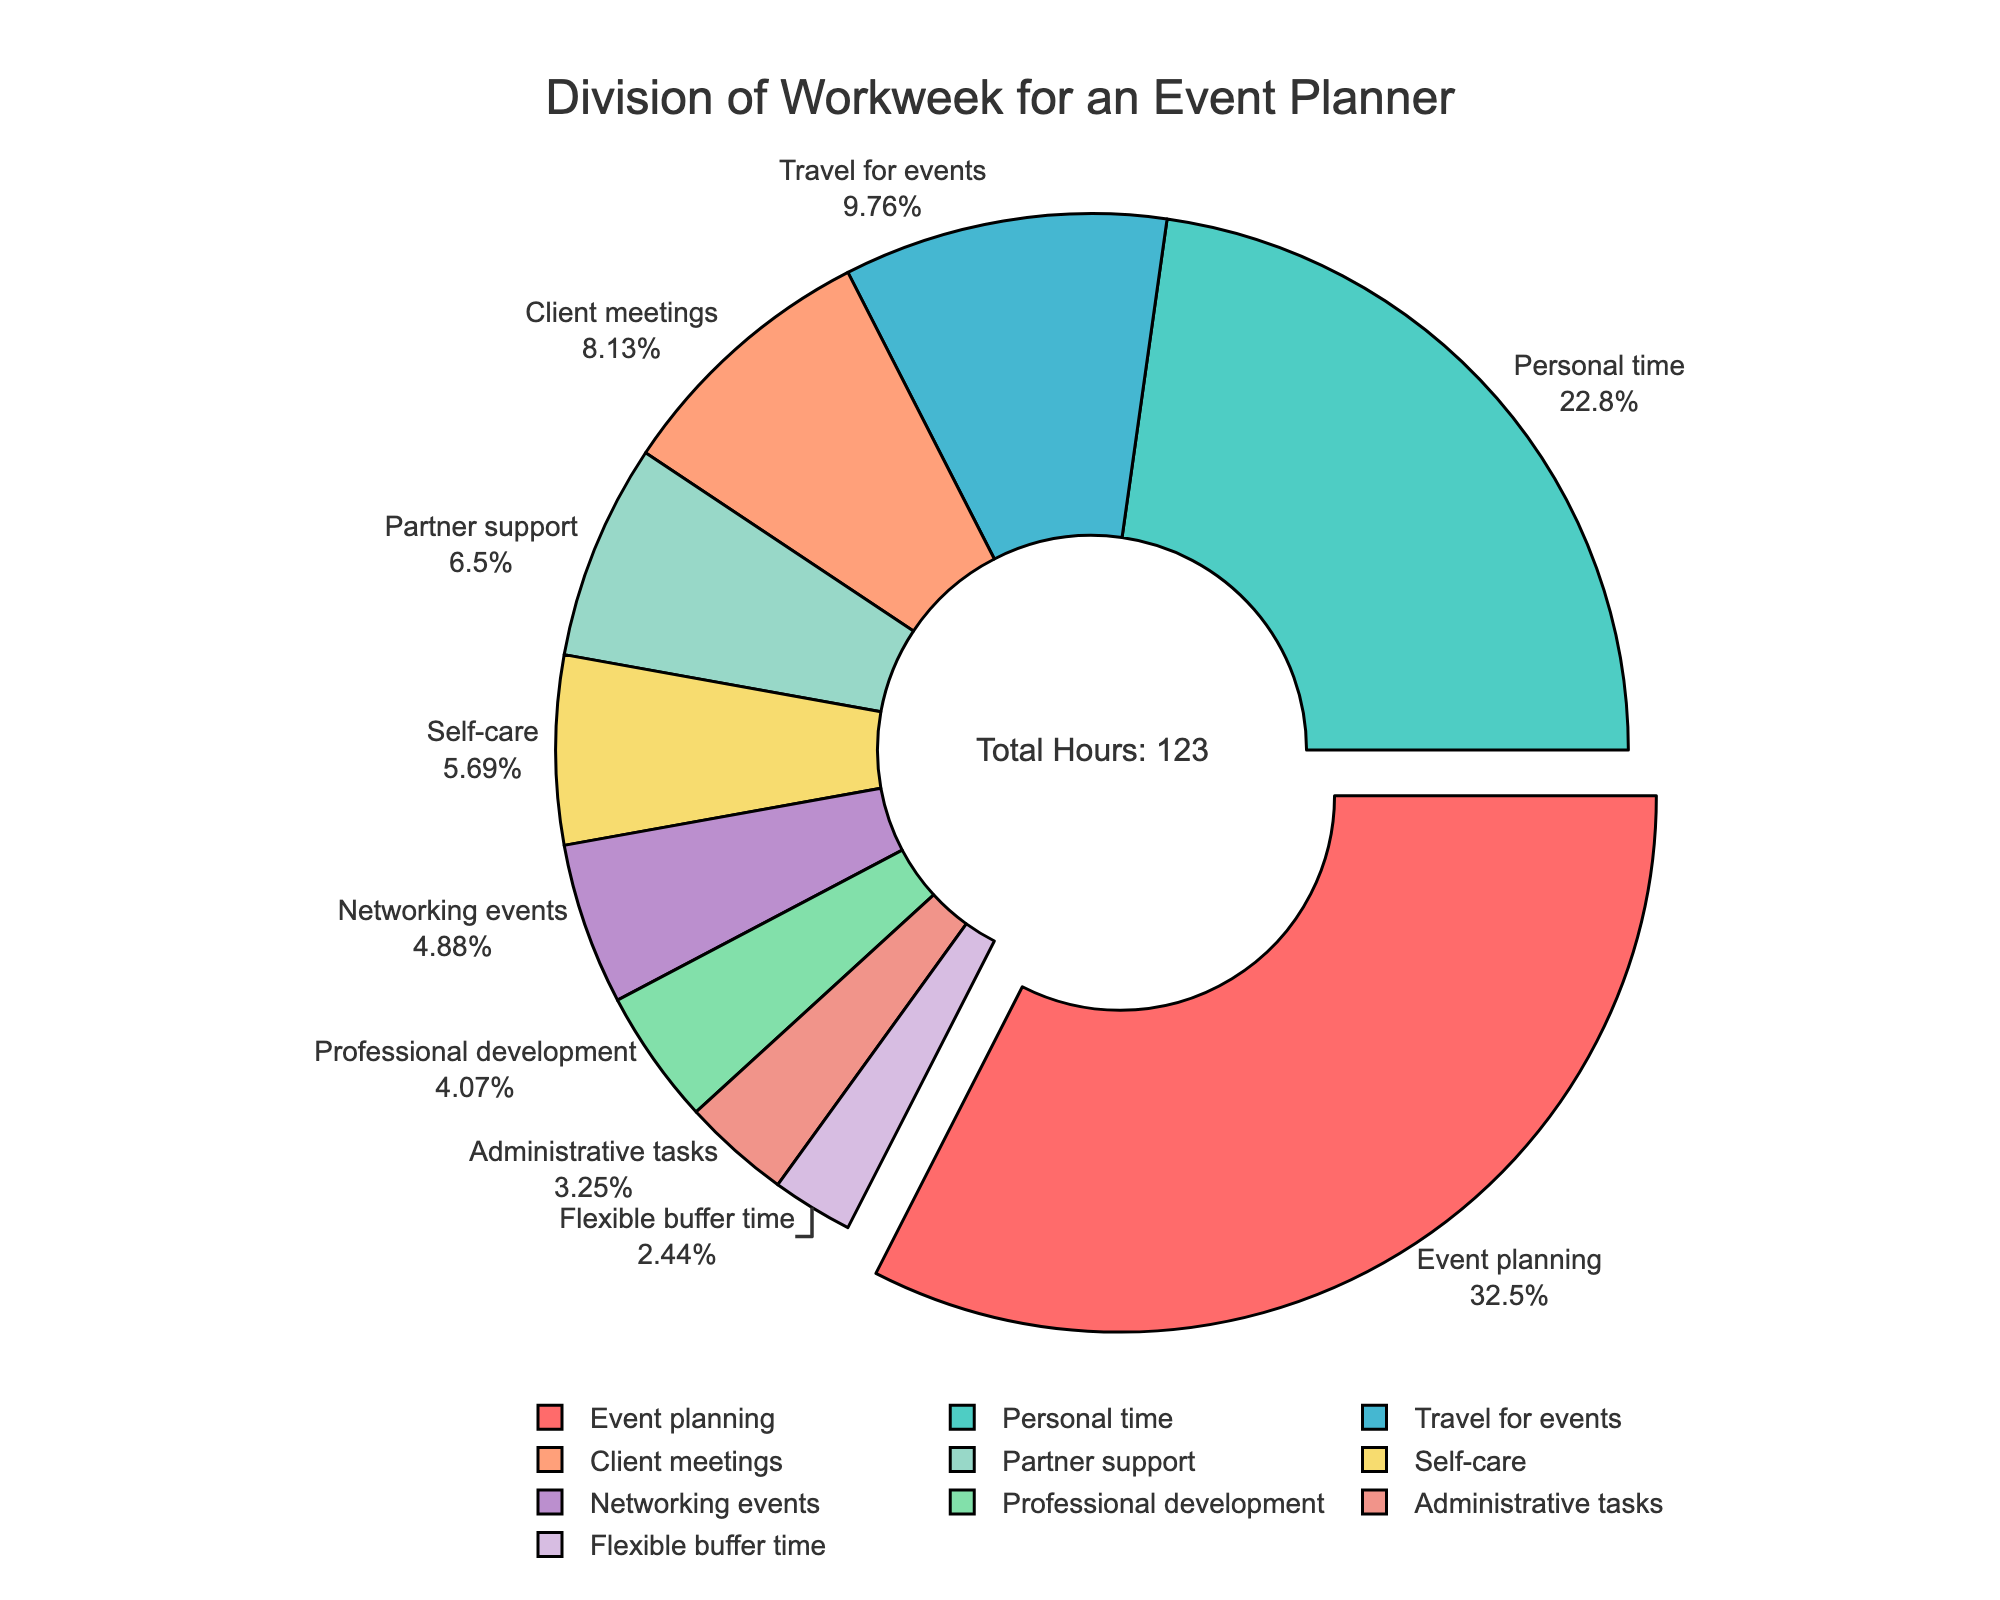What activity takes the largest portion of the workweek? We can see from the pie chart that the largest portion of the workweek is indicated by the largest slice. The largest slice is for "Event planning."
Answer: Event planning What percentage of the workweek is dedicated to personal time? The pie chart shows the percentage values on the slices. The slice for "Personal time" is labeled with its percentage, which is 20%.
Answer: 20% Which activity occupies more hours, Travel for events or Client meetings? By comparing the slices for "Travel for events" and "Client meetings," we can see that "Travel for events" shows 12 hours while "Client meetings" shows 10 hours.
Answer: Travel for events How many total hours are spent on self-care and partner support combined? To find the total hours, we need to add the hours spent on "Self-care" which is 7 hours, and the hours on "Partner support" which is 8 hours. 7 + 8 = 15.
Answer: 15 If the hours for event planning were reduced by 10% and added to personal time, what would be the new total hours for personal time? We first calculate 10% of the hours for "Event planning," which is 10% of 40 = 4 hours. Adding these hours to "Personal time," we get 28 + 4 = 32 hours.
Answer: 32 Is professional development more than half of the time spent on networking events? Professional development takes 5 hours, and networking events take 6 hours. Half of the networking events' time is 6/2 = 3 hours. Since 5 hours is greater than 3 hours, professional development is more than half of networking events.
Answer: Yes What is the difference in hours between the time spent on administrative tasks and flexible buffer time? Administrative tasks take 4 hours, and flexible buffer time takes 3 hours. The difference is 4 - 3 = 1 hour.
Answer: 1 hour How many hours are dedicated to activities related to the job (including event planning, travel for events, client meetings, networking events, professional development, and administrative tasks)? Summing the hours for job-related activities: Event planning (40), Travel for events (12), Client meetings (10), Networking events (6), Professional development (5), and Administrative tasks (4). The total is 40 + 12 + 10 + 6 + 5 + 4 = 77 hours.
Answer: 77 hours Of the two largest activities in terms of hours, what percentage of the total workweek do they represent together? The two largest activities are "Event planning" (40 hours) and "Personal time" (28 hours). The total workweek is 115 hours. The combined percentage is ((40 + 28) / 115) * 100 = 59%.
Answer: 59% Which activities are represented by slices with similar colors, and how can they be visually identified? The pie chart utilizes distinct colors for various sections. Close colors in the chart may be compared visually (e.g., shades of blue or green). By focusing on color proximity, we see that "Travel for events" (cyan) and "Client meetings" (salmon pink) are visually distinct. Other slices have similarly unique colors making it easy to identify them individually.
Answer: Travel for events - cyan; Client meetings - salmon pink 